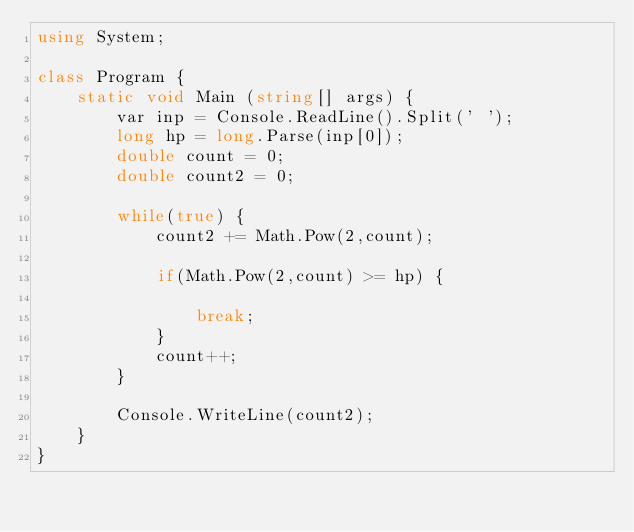Convert code to text. <code><loc_0><loc_0><loc_500><loc_500><_C#_>using System;

class Program {
    static void Main (string[] args) {
        var inp = Console.ReadLine().Split(' ');
        long hp = long.Parse(inp[0]);
        double count = 0;
        double count2 = 0;

        while(true) {
            count2 += Math.Pow(2,count);

            if(Math.Pow(2,count) >= hp) {

                break;
            }
            count++;
        }

        Console.WriteLine(count2);
    }
}</code> 